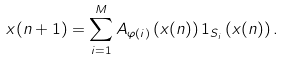Convert formula to latex. <formula><loc_0><loc_0><loc_500><loc_500>x ( n + 1 ) = \sum _ { i = 1 } ^ { M } A _ { \varphi ( i ) } \left ( x ( n ) \right ) { 1 } _ { S _ { i } } \left ( x ( n ) \right ) .</formula> 